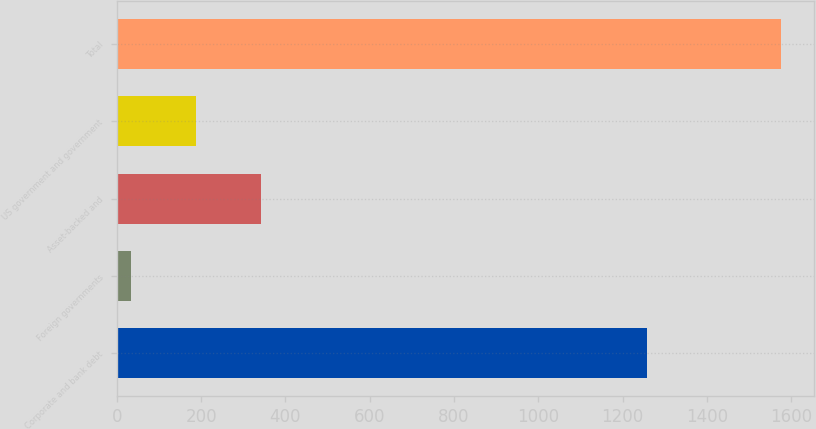Convert chart to OTSL. <chart><loc_0><loc_0><loc_500><loc_500><bar_chart><fcel>Corporate and bank debt<fcel>Foreign governments<fcel>Asset-backed and<fcel>US government and government<fcel>Total<nl><fcel>1257<fcel>33<fcel>341.4<fcel>187.2<fcel>1575<nl></chart> 